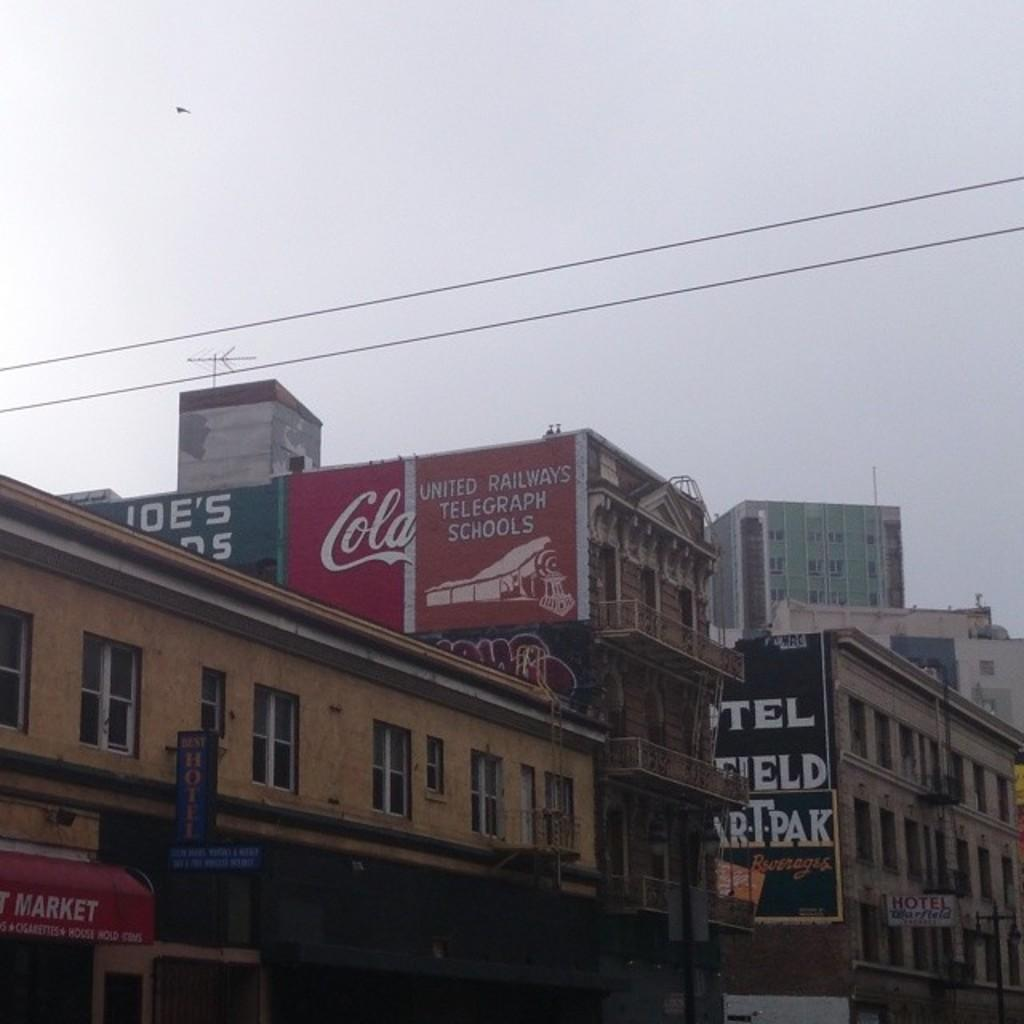Provide a one-sentence caption for the provided image. Buildings that have banners for cola and markets. 